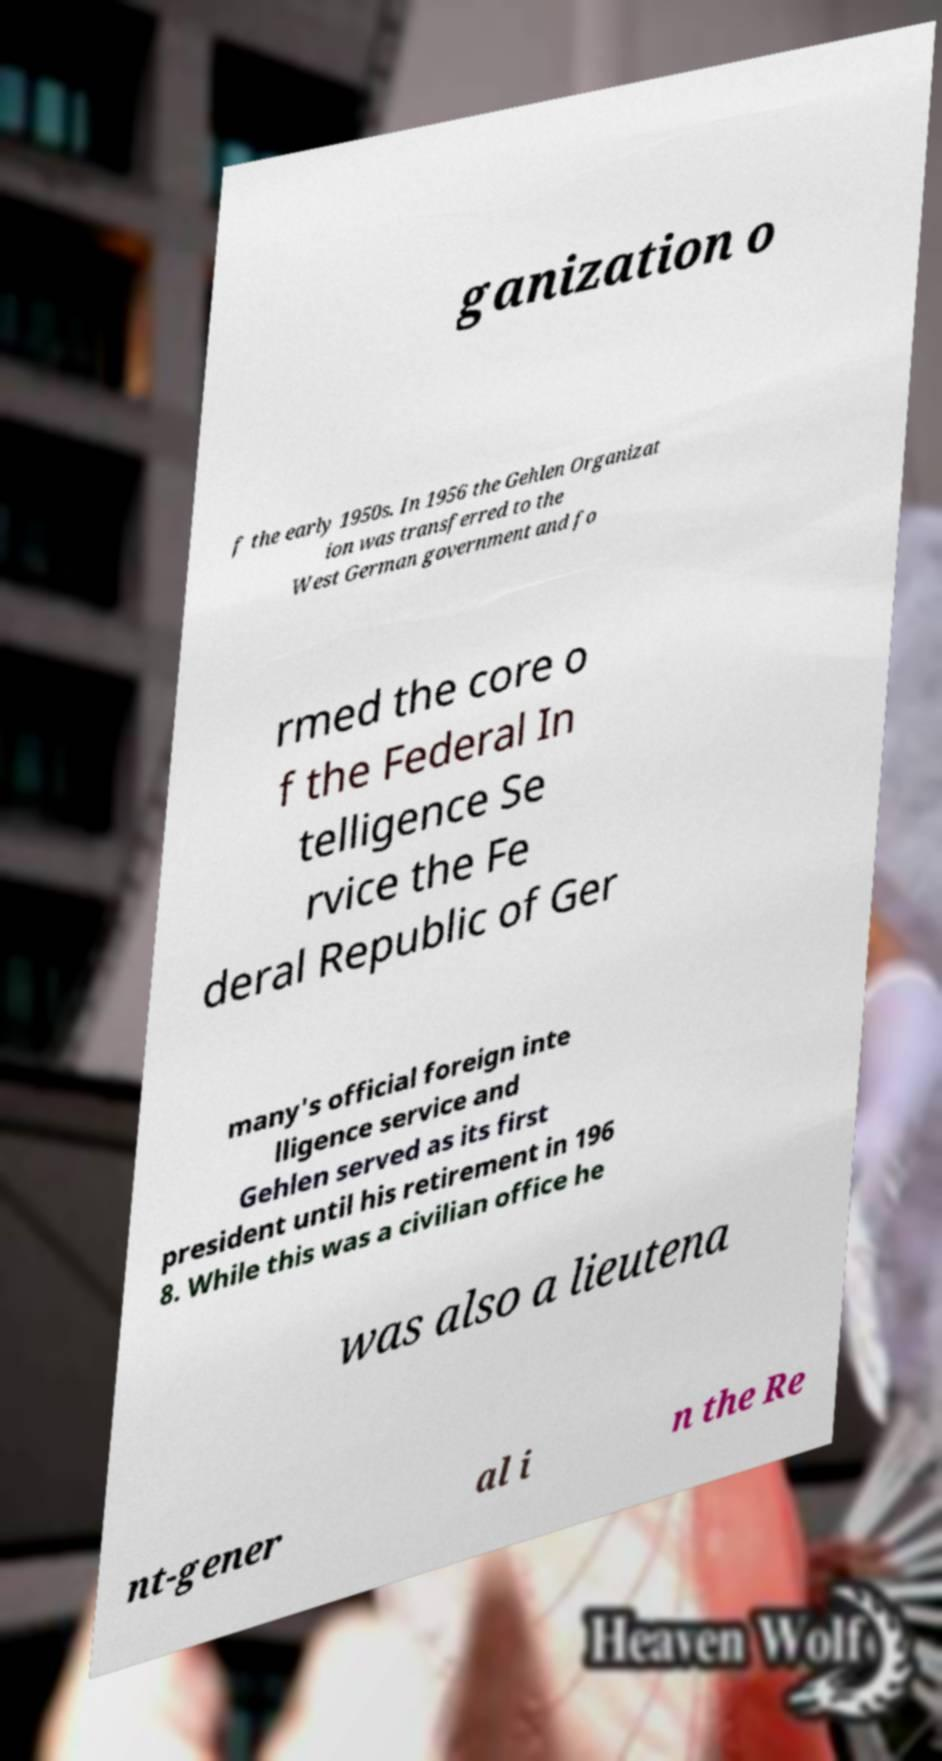I need the written content from this picture converted into text. Can you do that? ganization o f the early 1950s. In 1956 the Gehlen Organizat ion was transferred to the West German government and fo rmed the core o f the Federal In telligence Se rvice the Fe deral Republic of Ger many's official foreign inte lligence service and Gehlen served as its first president until his retirement in 196 8. While this was a civilian office he was also a lieutena nt-gener al i n the Re 